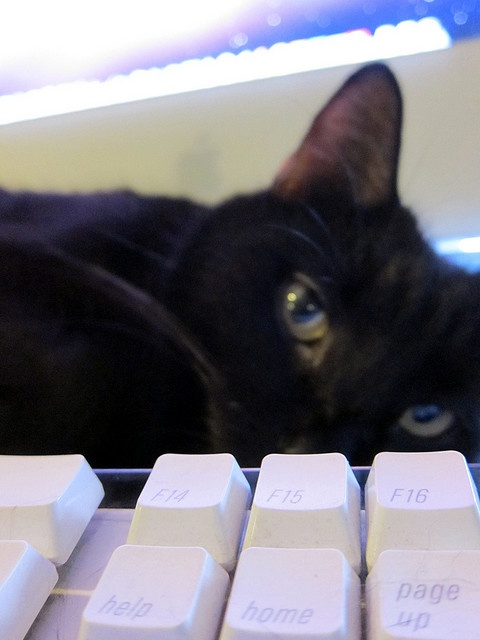Describe the objects in this image and their specific colors. I can see cat in white, black, gray, and navy tones, keyboard in white, lavender, darkgray, and lightgray tones, and tv in white, lightblue, and blue tones in this image. 